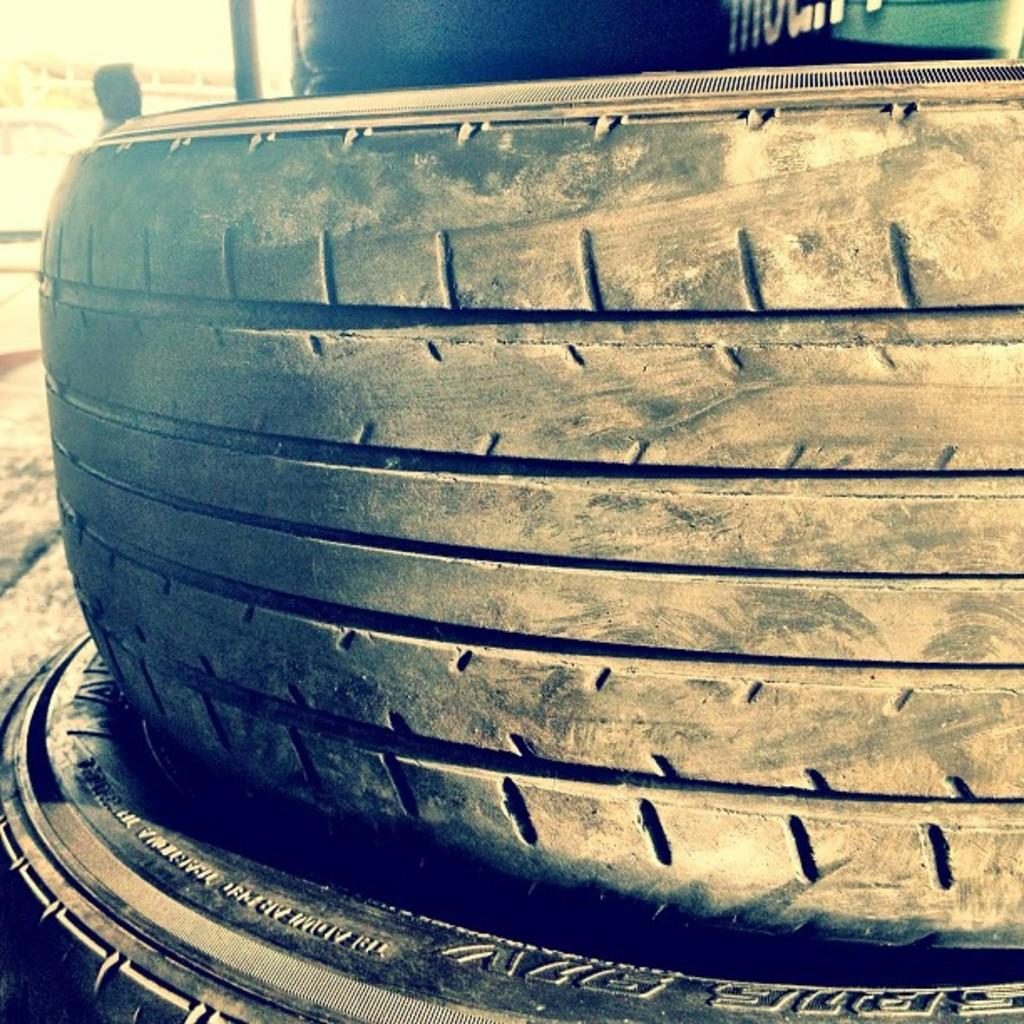What objects are present in the image? There are two tyres in the image. Can you describe the background of the image? There are objects in the background of the image. How many passengers are sitting on the chairs in the image? There are no chairs or passengers present in the image; it only features two tyres. 